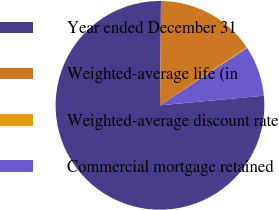Convert chart. <chart><loc_0><loc_0><loc_500><loc_500><pie_chart><fcel>Year ended December 31<fcel>Weighted-average life (in<fcel>Weighted-average discount rate<fcel>Commercial mortgage retained<nl><fcel>76.64%<fcel>15.44%<fcel>0.14%<fcel>7.79%<nl></chart> 